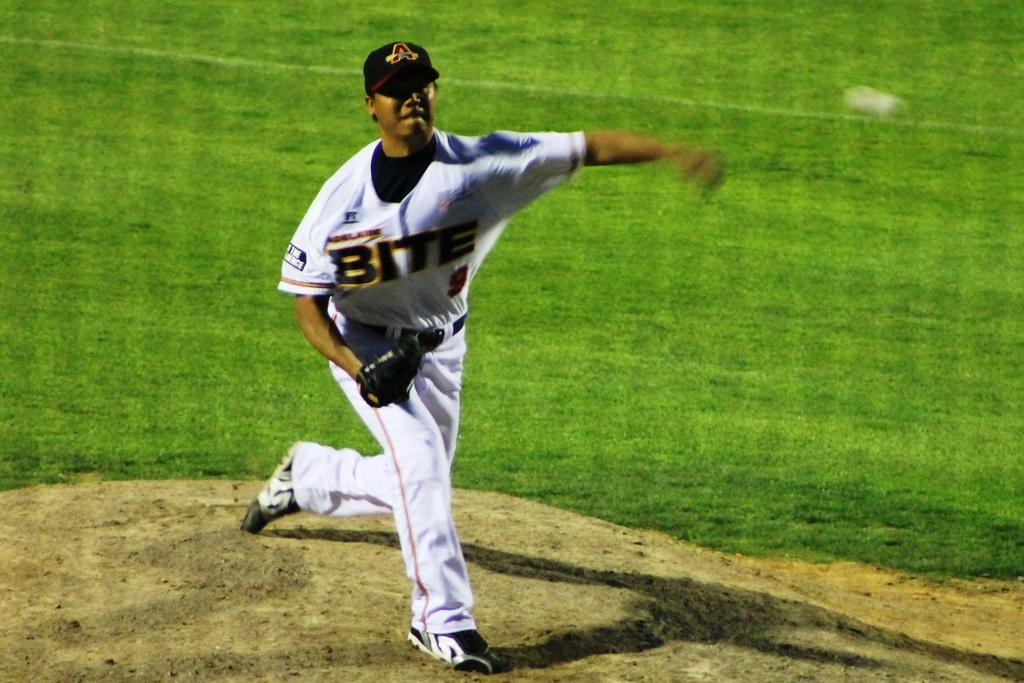<image>
Create a compact narrative representing the image presented. A baseball player in a Bite jersey throws a baseball. 